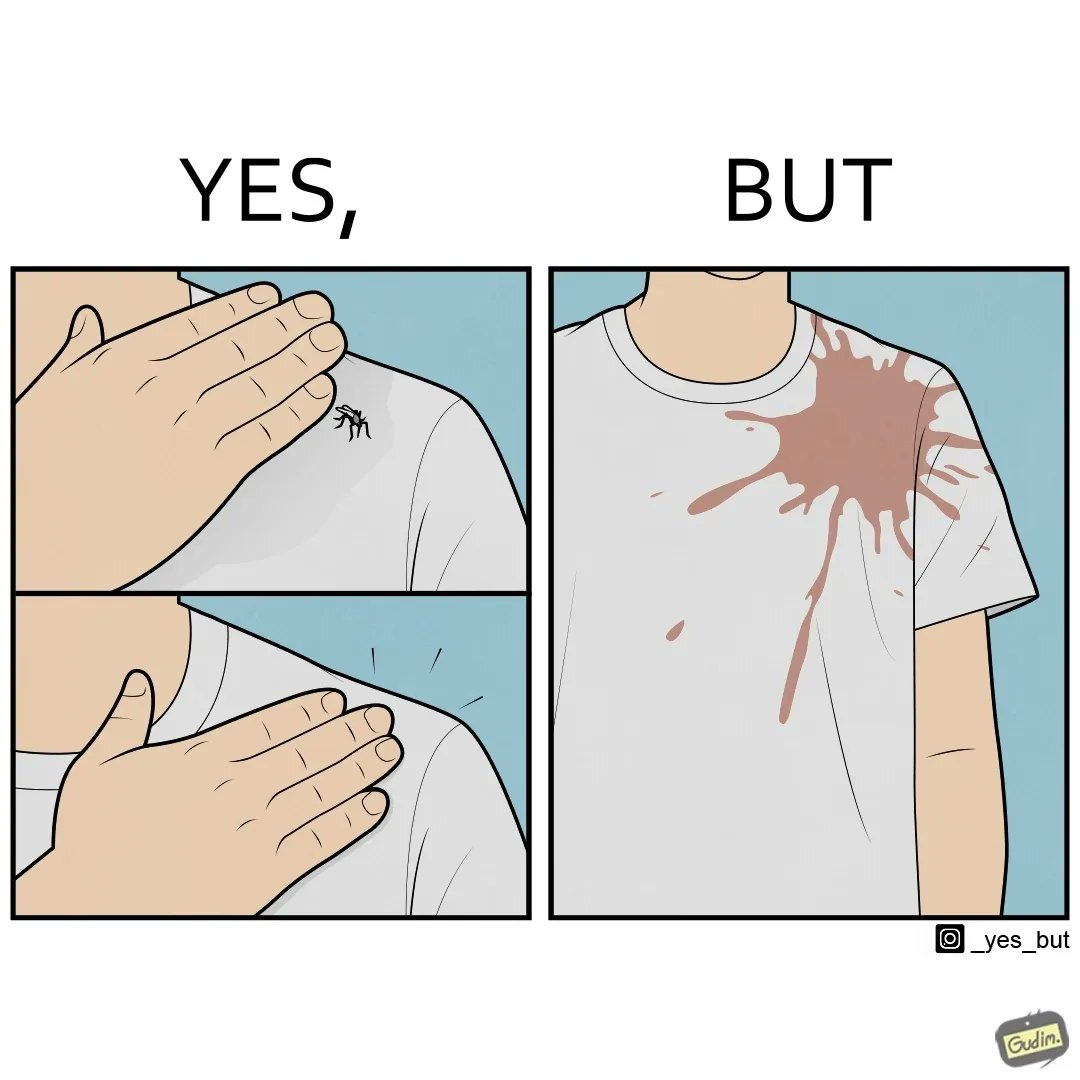Explain why this image is satirical. The images are funny since a man trying to reduce his irritation by killing a mosquito bothering  him only causes himself more irritation by soiling his t-shirt with the mosquito blood 